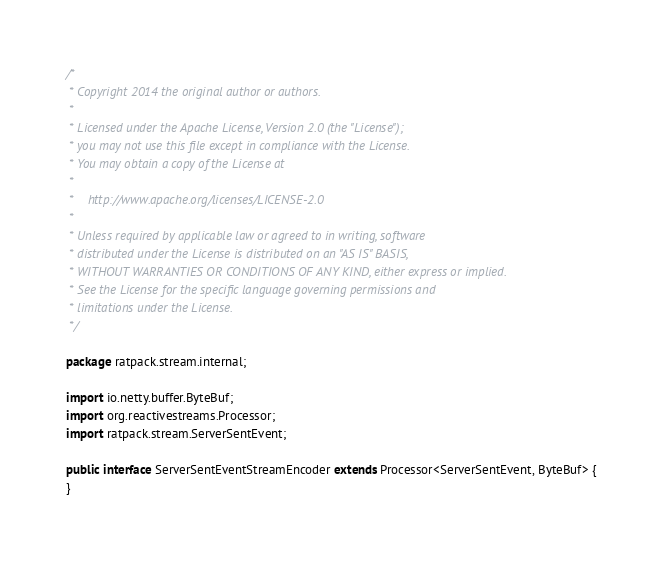<code> <loc_0><loc_0><loc_500><loc_500><_Java_>/*
 * Copyright 2014 the original author or authors.
 *
 * Licensed under the Apache License, Version 2.0 (the "License");
 * you may not use this file except in compliance with the License.
 * You may obtain a copy of the License at
 *
 *    http://www.apache.org/licenses/LICENSE-2.0
 *
 * Unless required by applicable law or agreed to in writing, software
 * distributed under the License is distributed on an "AS IS" BASIS,
 * WITHOUT WARRANTIES OR CONDITIONS OF ANY KIND, either express or implied.
 * See the License for the specific language governing permissions and
 * limitations under the License.
 */

package ratpack.stream.internal;

import io.netty.buffer.ByteBuf;
import org.reactivestreams.Processor;
import ratpack.stream.ServerSentEvent;

public interface ServerSentEventStreamEncoder extends Processor<ServerSentEvent, ByteBuf> {
}
</code> 